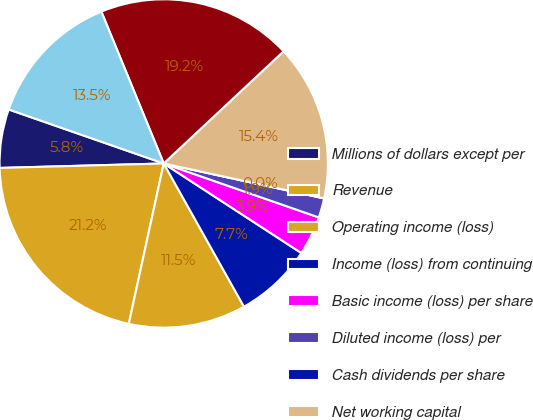<chart> <loc_0><loc_0><loc_500><loc_500><pie_chart><fcel>Millions of dollars except per<fcel>Revenue<fcel>Operating income (loss)<fcel>Income (loss) from continuing<fcel>Basic income (loss) per share<fcel>Diluted income (loss) per<fcel>Cash dividends per share<fcel>Net working capital<fcel>Total assets<fcel>Long-term debt (including<nl><fcel>5.77%<fcel>21.15%<fcel>11.54%<fcel>7.69%<fcel>3.85%<fcel>1.92%<fcel>0.0%<fcel>15.38%<fcel>19.23%<fcel>13.46%<nl></chart> 